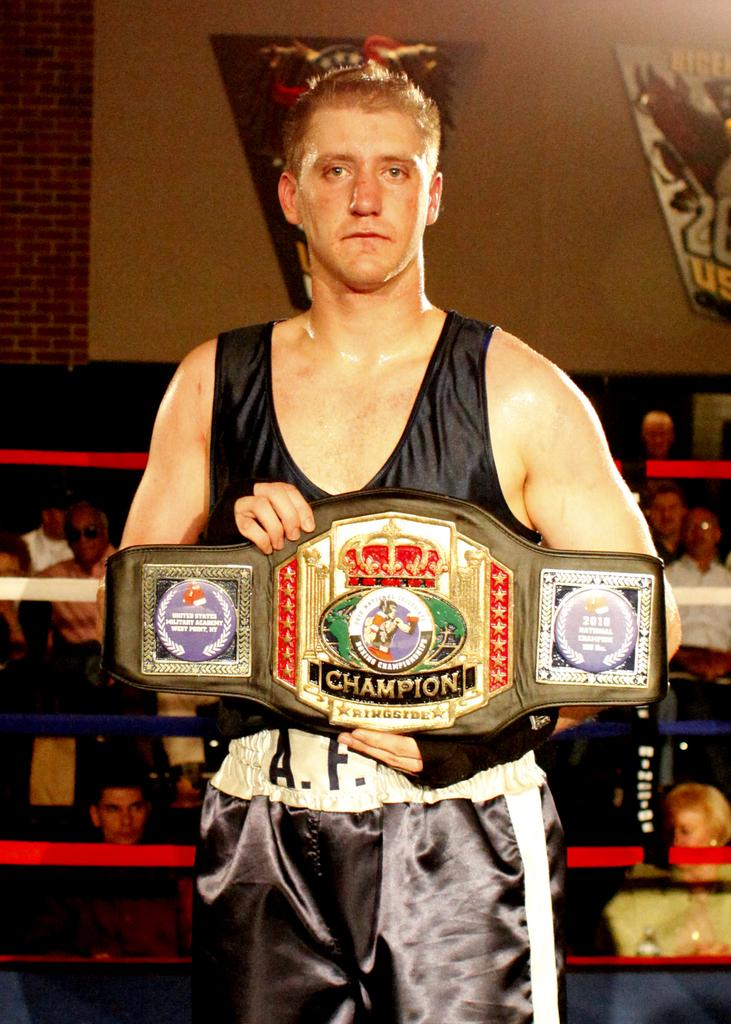Provide a one-sentence caption for the provided image. A young man presenting a championship belt of some type with champion ringside written on it. 